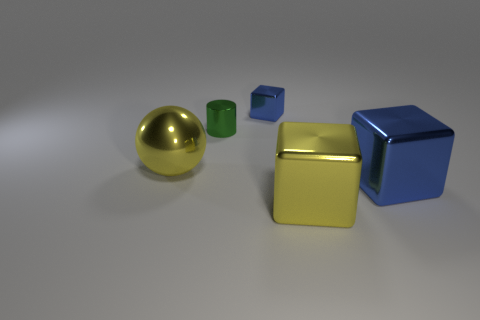Could you describe the lighting and atmosphere of the scene? The scene is softly lit, suggesting a calm and neutral atmosphere. The light source appears to be coming from the top left, creating gentle shadows to the right of the objects. This implies a diffuse lighting setup, often used in product photography to enhance the objects' colors and textures without causing harsh glare or reflections. 